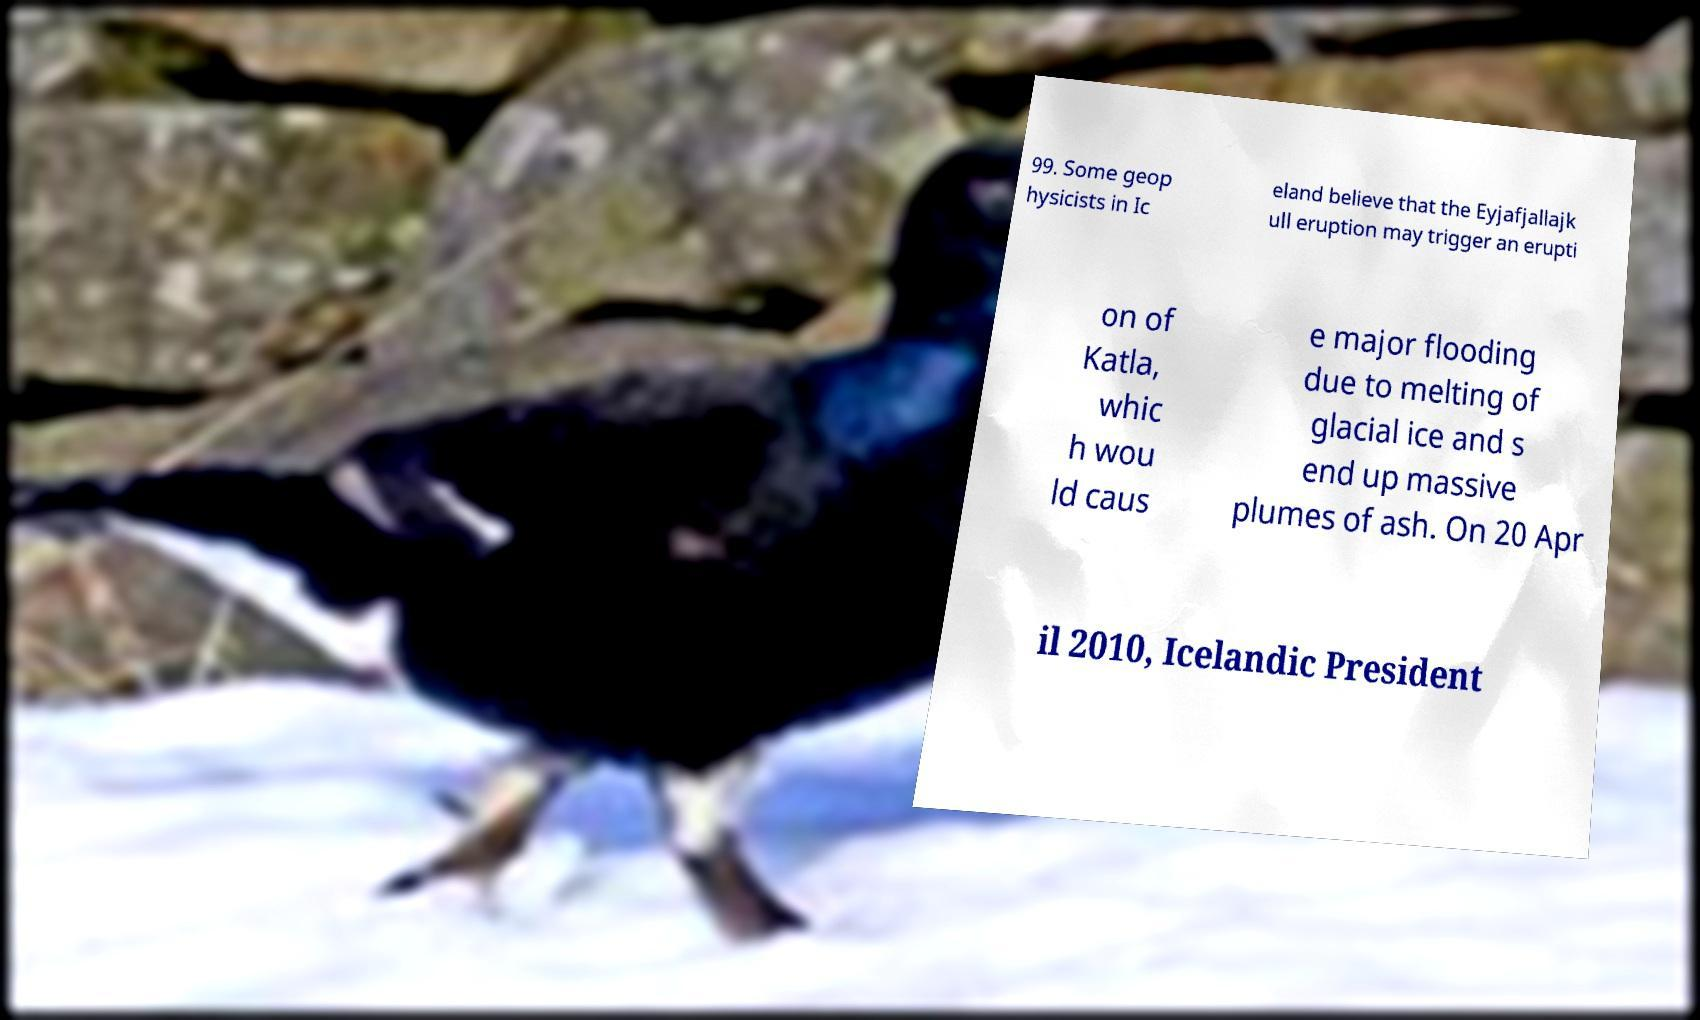Can you read and provide the text displayed in the image?This photo seems to have some interesting text. Can you extract and type it out for me? 99. Some geop hysicists in Ic eland believe that the Eyjafjallajk ull eruption may trigger an erupti on of Katla, whic h wou ld caus e major flooding due to melting of glacial ice and s end up massive plumes of ash. On 20 Apr il 2010, Icelandic President 